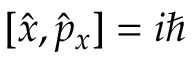<formula> <loc_0><loc_0><loc_500><loc_500>[ { \hat { x } } , { \hat { p } } _ { x } ] = i \hbar</formula> 